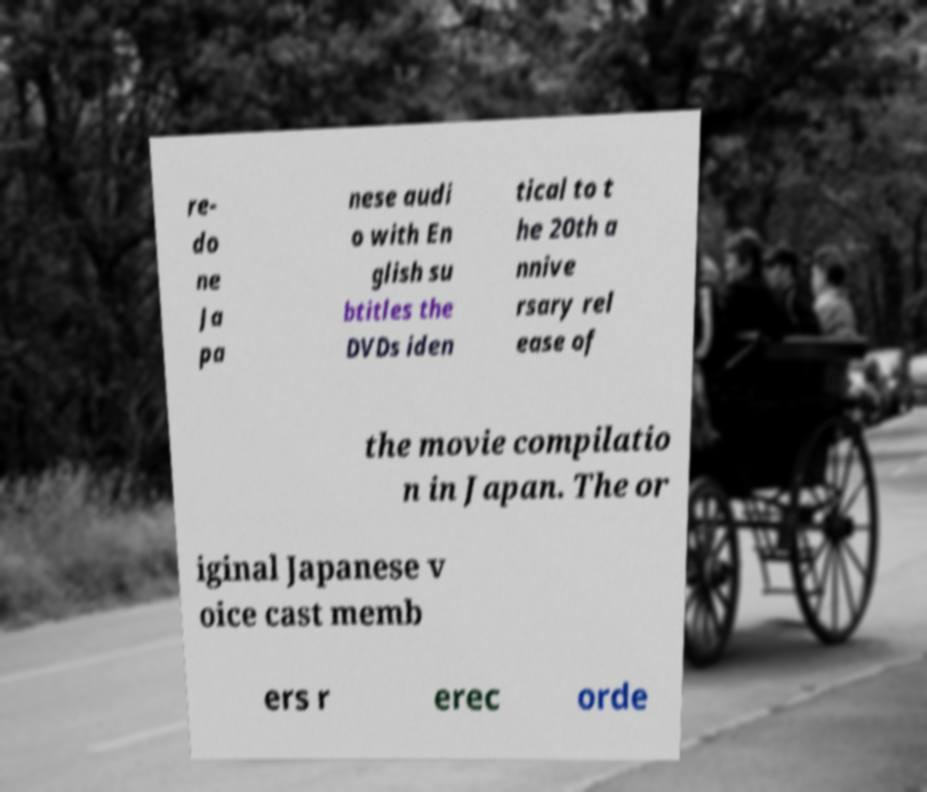Could you extract and type out the text from this image? re- do ne Ja pa nese audi o with En glish su btitles the DVDs iden tical to t he 20th a nnive rsary rel ease of the movie compilatio n in Japan. The or iginal Japanese v oice cast memb ers r erec orde 